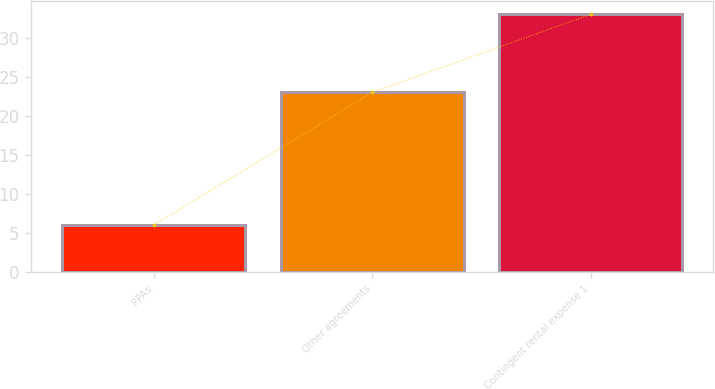Convert chart to OTSL. <chart><loc_0><loc_0><loc_500><loc_500><bar_chart><fcel>PPAs<fcel>Other agreements<fcel>Contingent rental expense 1<nl><fcel>6<fcel>23<fcel>33<nl></chart> 